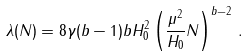<formula> <loc_0><loc_0><loc_500><loc_500>\lambda ( N ) = 8 \gamma ( b - 1 ) b H _ { 0 } ^ { 2 } \left ( \frac { \mu ^ { 2 } } { H _ { 0 } } N \right ) ^ { b - 2 } \, .</formula> 